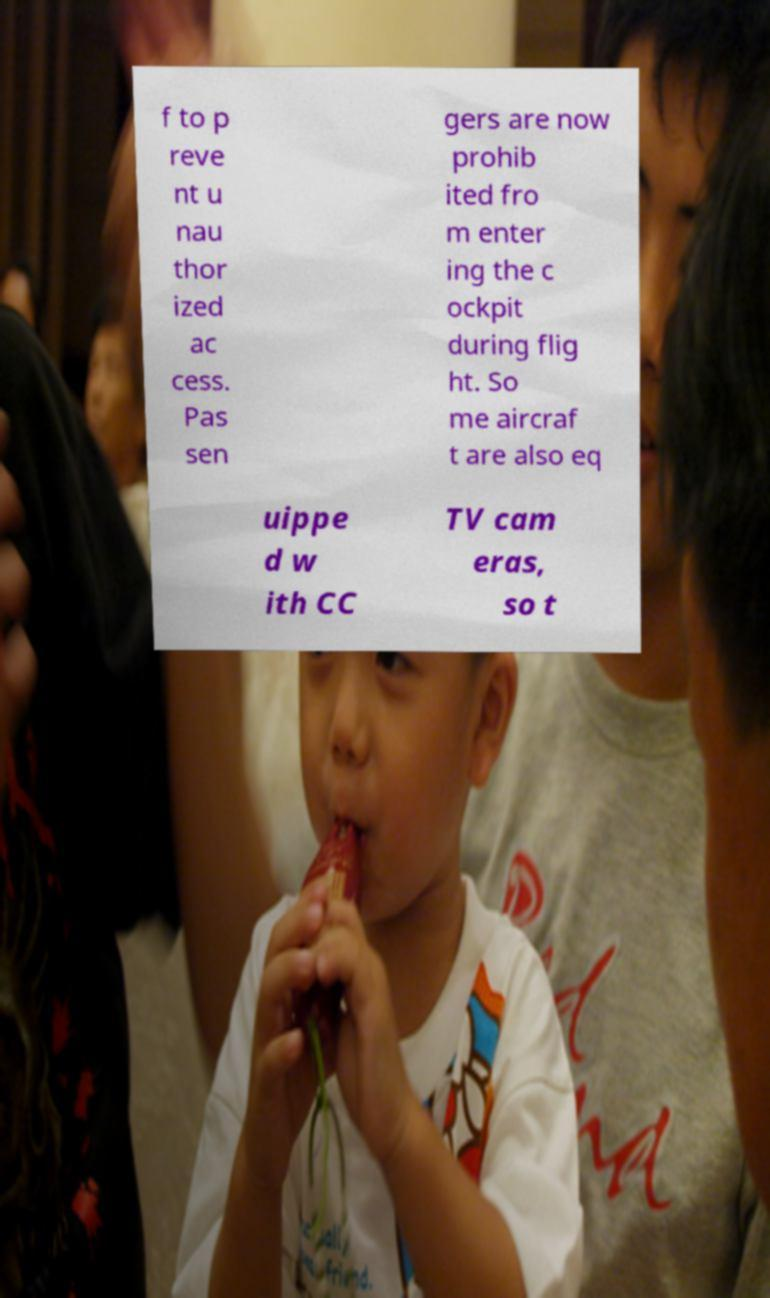Could you extract and type out the text from this image? f to p reve nt u nau thor ized ac cess. Pas sen gers are now prohib ited fro m enter ing the c ockpit during flig ht. So me aircraf t are also eq uippe d w ith CC TV cam eras, so t 